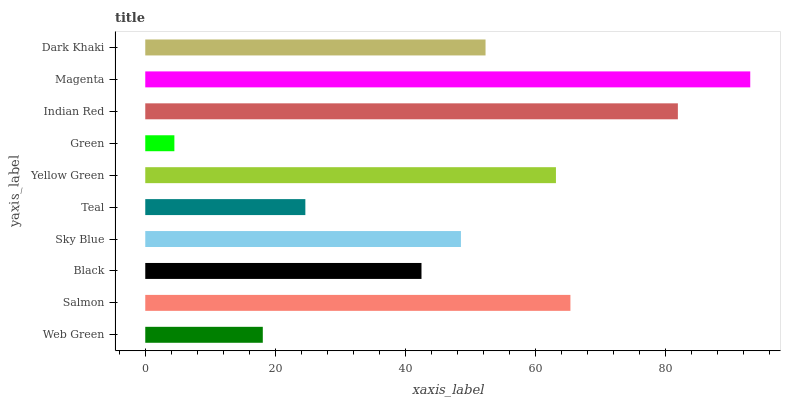Is Green the minimum?
Answer yes or no. Yes. Is Magenta the maximum?
Answer yes or no. Yes. Is Salmon the minimum?
Answer yes or no. No. Is Salmon the maximum?
Answer yes or no. No. Is Salmon greater than Web Green?
Answer yes or no. Yes. Is Web Green less than Salmon?
Answer yes or no. Yes. Is Web Green greater than Salmon?
Answer yes or no. No. Is Salmon less than Web Green?
Answer yes or no. No. Is Dark Khaki the high median?
Answer yes or no. Yes. Is Sky Blue the low median?
Answer yes or no. Yes. Is Teal the high median?
Answer yes or no. No. Is Yellow Green the low median?
Answer yes or no. No. 